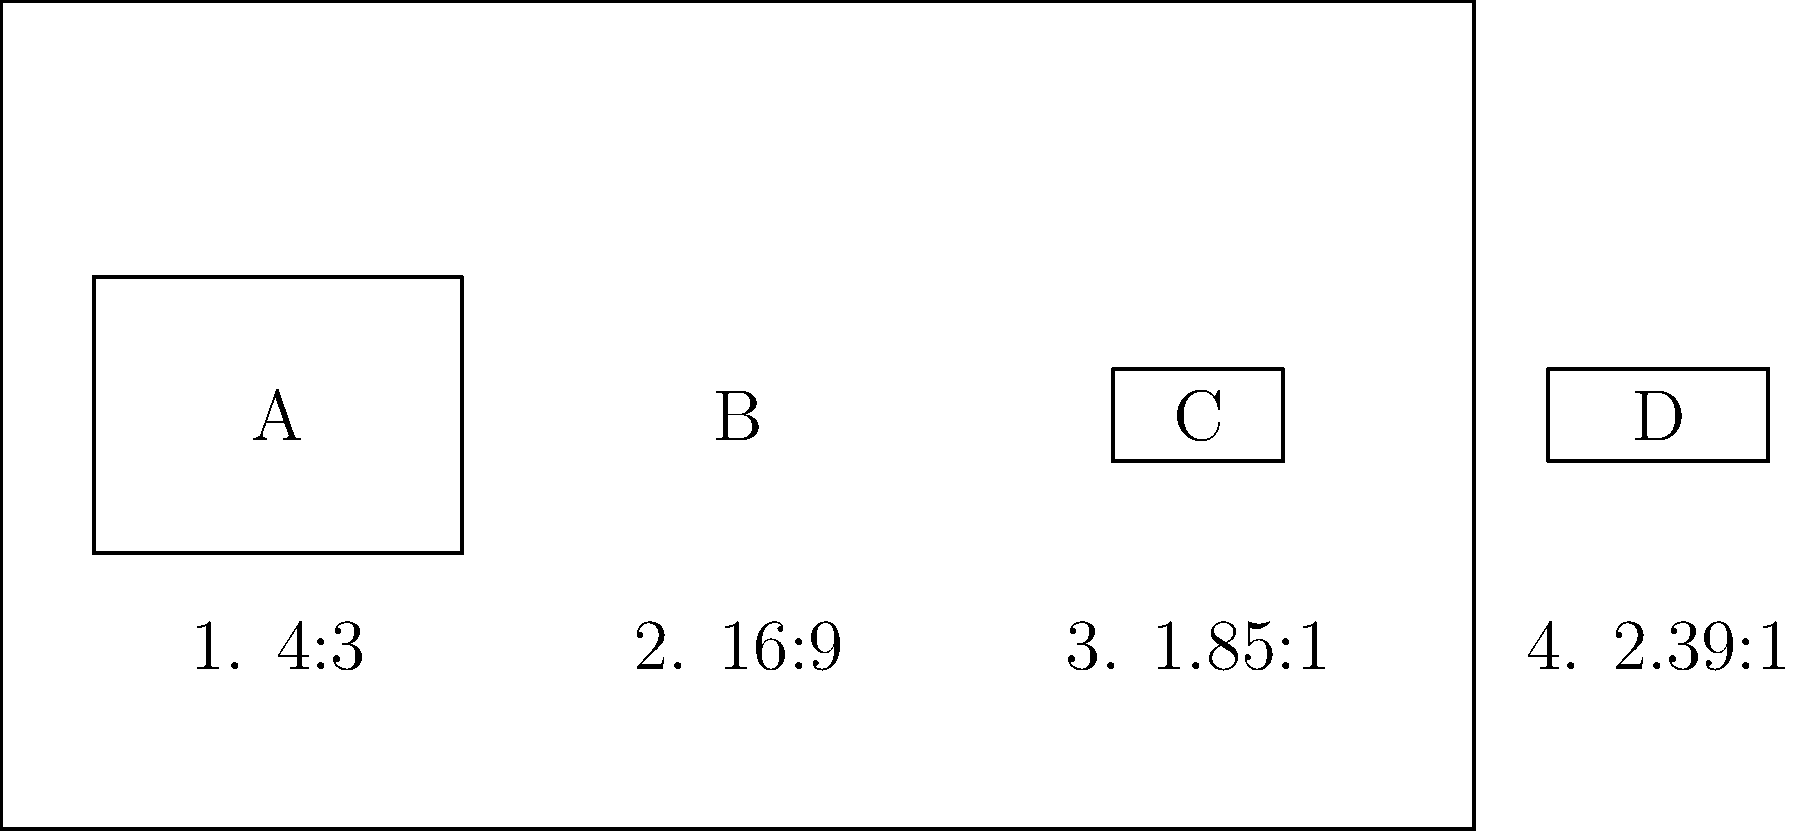As a film journalist, you're familiar with various aspect ratios used in cinema. Match the film posters (A, B, C, D) with their correct aspect ratios (1, 2, 3, 4) based on their visual proportions. To match the film posters with their correct aspect ratios, we need to analyze the proportions of each poster:

1. Poster A: This poster has a nearly square shape, with the width slightly larger than the height. This corresponds to the classic 4:3 aspect ratio, which is option 1.

2. Poster B: This poster is noticeably wider than it is tall, but not extremely wide. It matches the 16:9 aspect ratio, which is commonly used in modern widescreen TVs and is option 2.

3. Poster C: This poster is wider than Poster A but not as wide as Poster B. It corresponds to the 1.85:1 aspect ratio, which is a common format for many films and is option 3.

4. Poster D: This is the widest poster of the group, matching the 2.39:1 aspect ratio, which is used for many widescreen theatrical releases and is option 4.

Therefore, the correct matches are:
A - 1 (4:3)
B - 2 (16:9)
C - 3 (1.85:1)
D - 4 (2.39:1)
Answer: A1, B2, C3, D4 